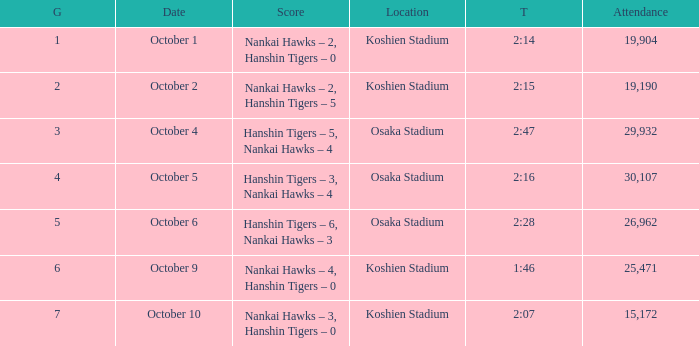How many games have an Attendance of 19,190? 1.0. 